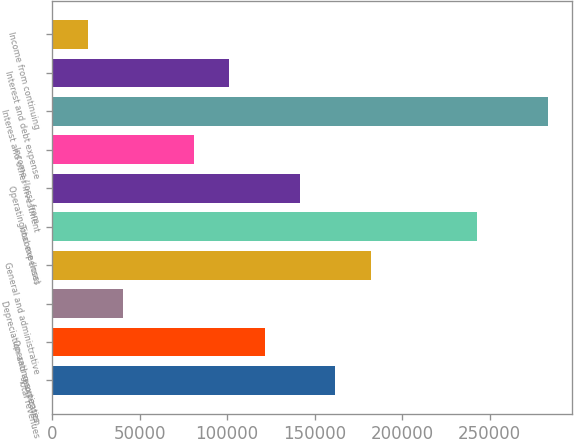<chart> <loc_0><loc_0><loc_500><loc_500><bar_chart><fcel>Total revenues<fcel>Operating expenses<fcel>Depreciation and amortization<fcel>General and administrative<fcel>Total expenses<fcel>Operating income (loss)<fcel>Income (loss) from<fcel>Interest and other investment<fcel>Interest and debt expense<fcel>Income from continuing<nl><fcel>161826<fcel>121374<fcel>40468.1<fcel>182053<fcel>242732<fcel>141600<fcel>80920.8<fcel>283184<fcel>101147<fcel>20241.8<nl></chart> 